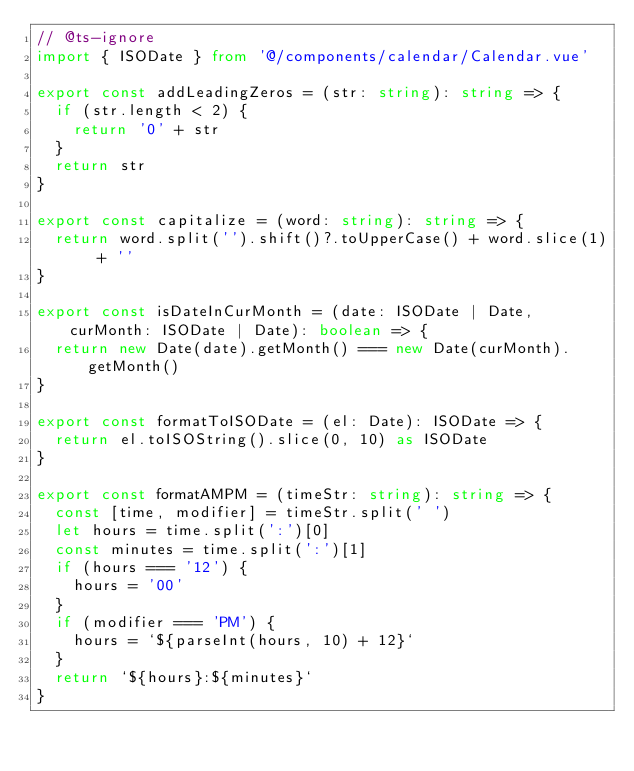<code> <loc_0><loc_0><loc_500><loc_500><_TypeScript_>// @ts-ignore
import { ISODate } from '@/components/calendar/Calendar.vue'

export const addLeadingZeros = (str: string): string => {
  if (str.length < 2) {
    return '0' + str
  }
  return str
}

export const capitalize = (word: string): string => {
  return word.split('').shift()?.toUpperCase() + word.slice(1) + ''
}

export const isDateInCurMonth = (date: ISODate | Date, curMonth: ISODate | Date): boolean => {
  return new Date(date).getMonth() === new Date(curMonth).getMonth()
}

export const formatToISODate = (el: Date): ISODate => {
  return el.toISOString().slice(0, 10) as ISODate
}

export const formatAMPM = (timeStr: string): string => {
  const [time, modifier] = timeStr.split(' ')
  let hours = time.split(':')[0]
  const minutes = time.split(':')[1]
  if (hours === '12') {
    hours = '00'
  }
  if (modifier === 'PM') {
    hours = `${parseInt(hours, 10) + 12}`
  }
  return `${hours}:${minutes}`
}
</code> 